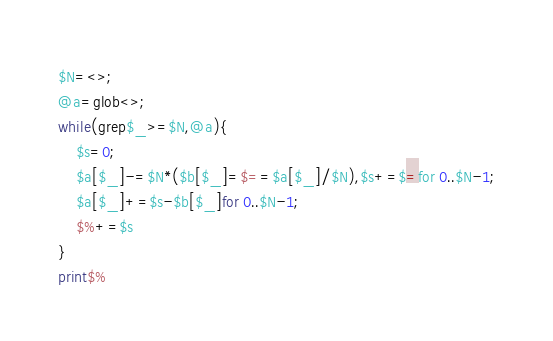Convert code to text. <code><loc_0><loc_0><loc_500><loc_500><_Perl_>$N=<>;
@a=glob<>;
while(grep$_>=$N,@a){
	$s=0;
	$a[$_]-=$N*($b[$_]=$==$a[$_]/$N),$s+=$=for 0..$N-1;
	$a[$_]+=$s-$b[$_]for 0..$N-1;
	$%+=$s
}
print$%
</code> 